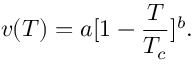Convert formula to latex. <formula><loc_0><loc_0><loc_500><loc_500>v ( T ) = a [ 1 - { \frac { T } { T _ { c } } } ] ^ { b } .</formula> 